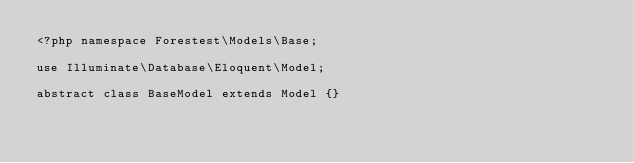<code> <loc_0><loc_0><loc_500><loc_500><_PHP_><?php namespace Forestest\Models\Base;

use Illuminate\Database\Eloquent\Model;

abstract class BaseModel extends Model {}
</code> 